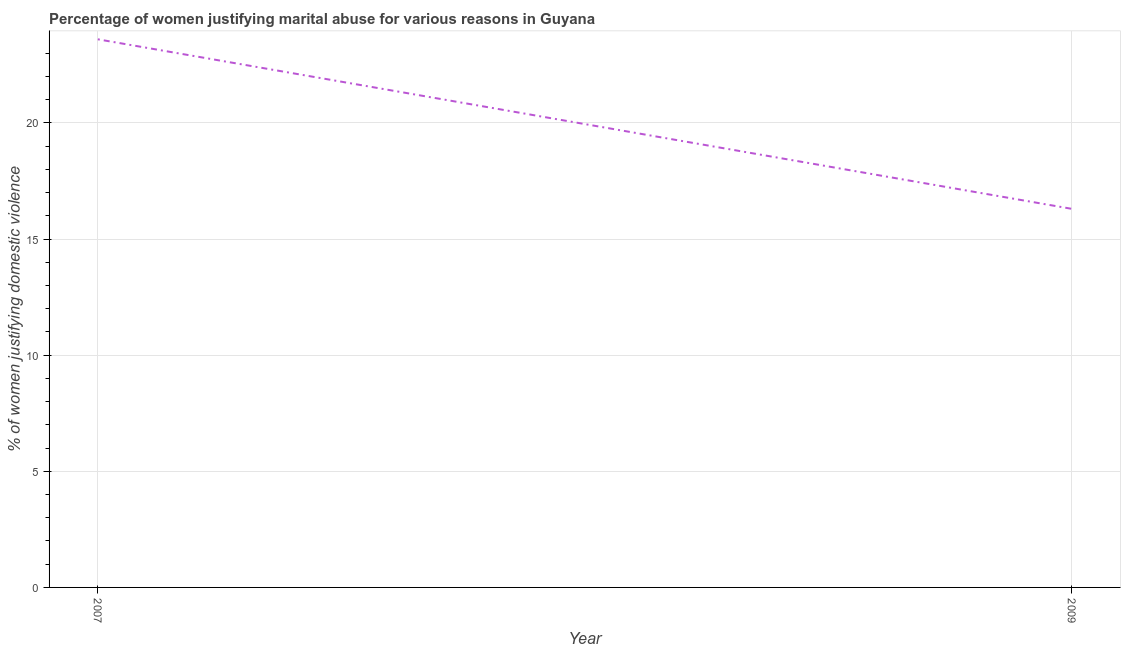Across all years, what is the maximum percentage of women justifying marital abuse?
Offer a very short reply. 23.6. Across all years, what is the minimum percentage of women justifying marital abuse?
Offer a very short reply. 16.3. In which year was the percentage of women justifying marital abuse maximum?
Give a very brief answer. 2007. In which year was the percentage of women justifying marital abuse minimum?
Keep it short and to the point. 2009. What is the sum of the percentage of women justifying marital abuse?
Provide a short and direct response. 39.9. What is the difference between the percentage of women justifying marital abuse in 2007 and 2009?
Your answer should be very brief. 7.3. What is the average percentage of women justifying marital abuse per year?
Offer a very short reply. 19.95. What is the median percentage of women justifying marital abuse?
Offer a very short reply. 19.95. What is the ratio of the percentage of women justifying marital abuse in 2007 to that in 2009?
Ensure brevity in your answer.  1.45. What is the difference between two consecutive major ticks on the Y-axis?
Offer a terse response. 5. Are the values on the major ticks of Y-axis written in scientific E-notation?
Keep it short and to the point. No. Does the graph contain any zero values?
Your answer should be very brief. No. Does the graph contain grids?
Give a very brief answer. Yes. What is the title of the graph?
Your answer should be very brief. Percentage of women justifying marital abuse for various reasons in Guyana. What is the label or title of the X-axis?
Your answer should be compact. Year. What is the label or title of the Y-axis?
Your answer should be very brief. % of women justifying domestic violence. What is the % of women justifying domestic violence in 2007?
Offer a terse response. 23.6. What is the difference between the % of women justifying domestic violence in 2007 and 2009?
Offer a terse response. 7.3. What is the ratio of the % of women justifying domestic violence in 2007 to that in 2009?
Offer a very short reply. 1.45. 